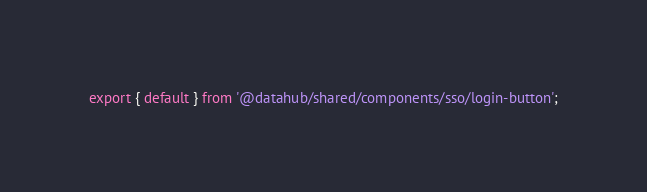<code> <loc_0><loc_0><loc_500><loc_500><_JavaScript_>export { default } from '@datahub/shared/components/sso/login-button';
</code> 